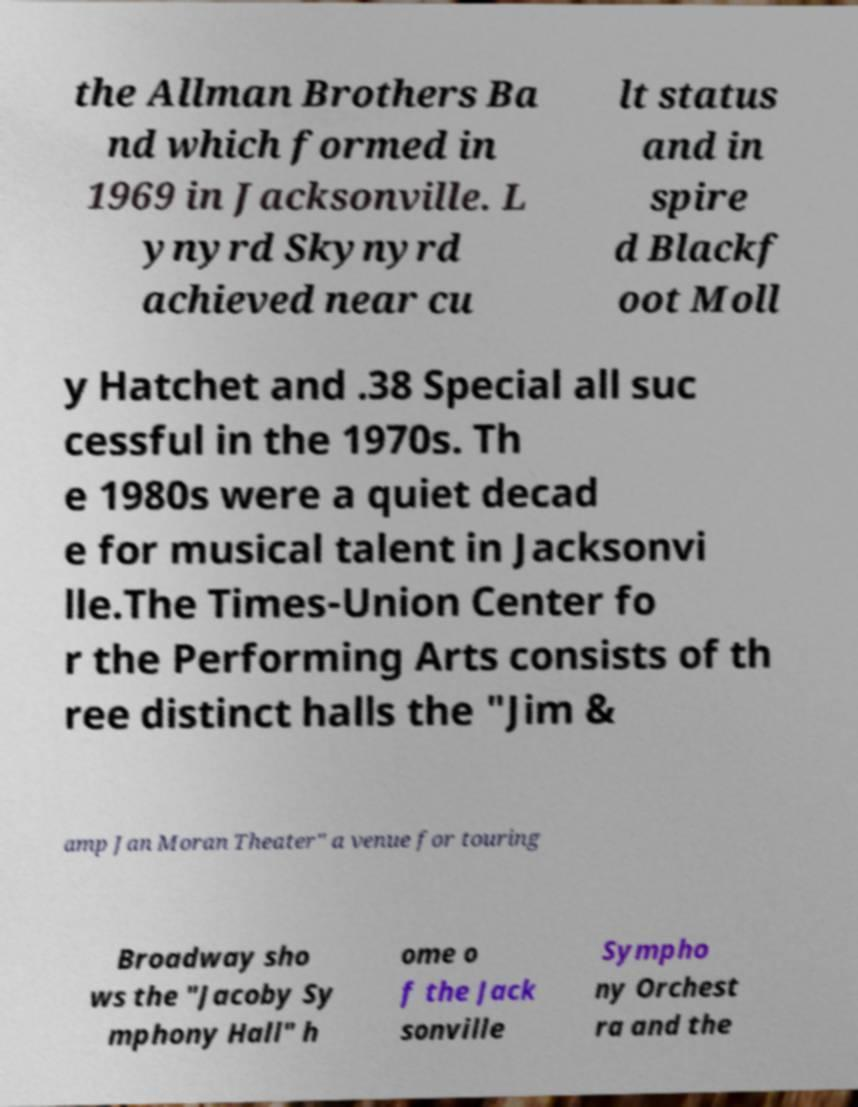Could you extract and type out the text from this image? the Allman Brothers Ba nd which formed in 1969 in Jacksonville. L ynyrd Skynyrd achieved near cu lt status and in spire d Blackf oot Moll y Hatchet and .38 Special all suc cessful in the 1970s. Th e 1980s were a quiet decad e for musical talent in Jacksonvi lle.The Times-Union Center fo r the Performing Arts consists of th ree distinct halls the "Jim & amp Jan Moran Theater" a venue for touring Broadway sho ws the "Jacoby Sy mphony Hall" h ome o f the Jack sonville Sympho ny Orchest ra and the 